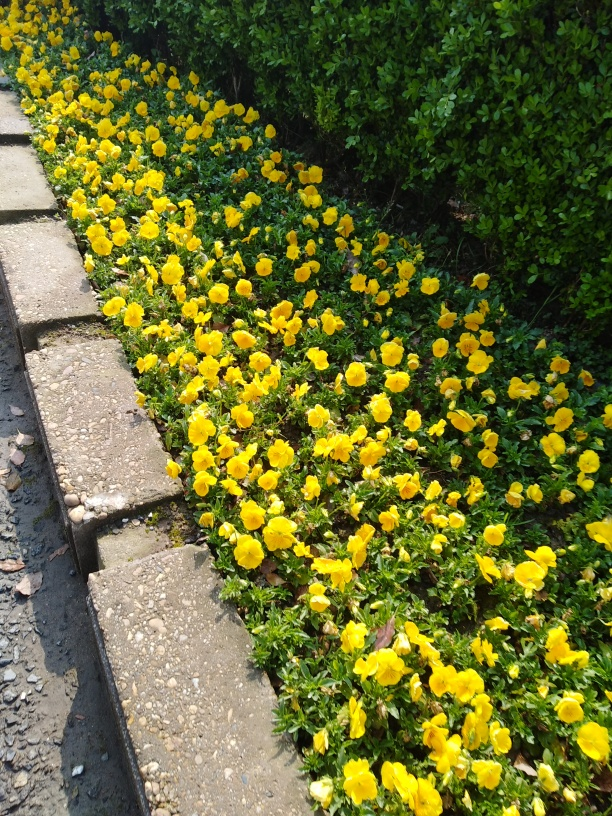Could you tell me about the care these flowers need? Pansies generally require well-drained soil and partial to full sunlight. Regular watering is essential, especially during dry periods, to keep the soil moist. Are these flowers resistant to cold weather? Pansies are fairly hardy and can withstand cooler temperatures. They are often planted in early spring and can survive light frosts. 